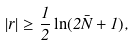<formula> <loc_0><loc_0><loc_500><loc_500>| r | \geq \frac { 1 } { 2 } \ln ( 2 \bar { N } + 1 ) ,</formula> 